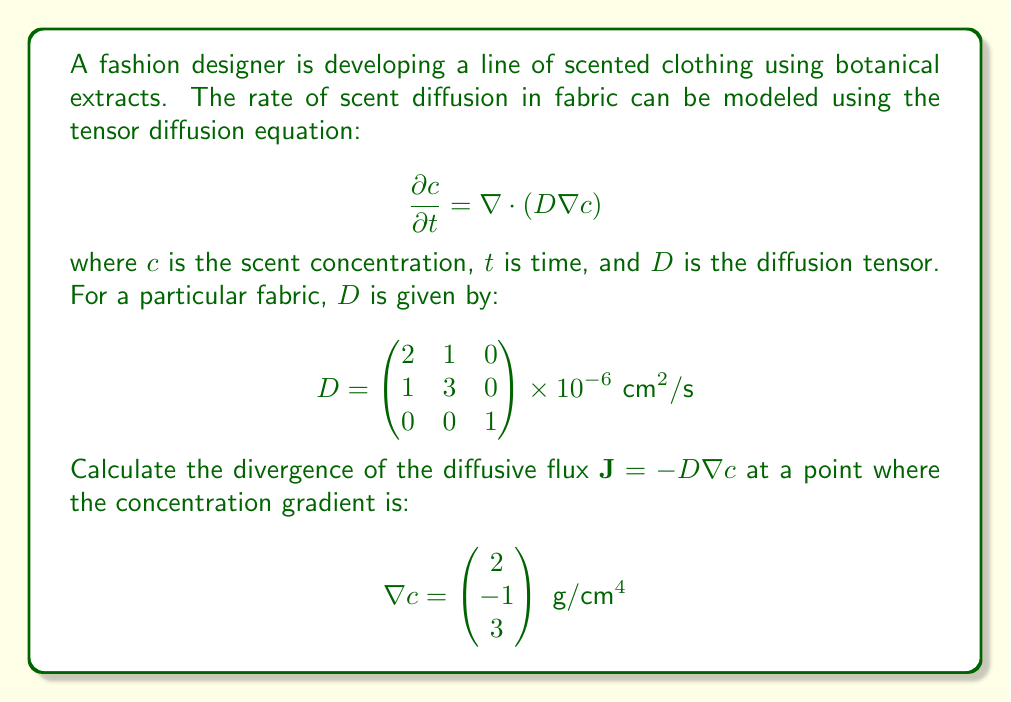Can you solve this math problem? Let's approach this step-by-step:

1) First, we need to calculate the diffusive flux $\mathbf{J} = -D \nabla c$:

   $$\mathbf{J} = -\begin{pmatrix} 
   2 & 1 & 0 \\
   1 & 3 & 0 \\
   0 & 0 & 1
   \end{pmatrix} \times 10^{-6} \begin{pmatrix} 
   2 \\
   -1 \\
   3
   \end{pmatrix}$$

2) Performing the matrix multiplication:

   $$\mathbf{J} = -\begin{pmatrix} 
   (2 \times 2 + 1 \times (-1) + 0 \times 3) \times 10^{-6} \\
   (1 \times 2 + 3 \times (-1) + 0 \times 3) \times 10^{-6} \\
   (0 \times 2 + 0 \times (-1) + 1 \times 3) \times 10^{-6}
   \end{pmatrix}$$

3) Simplifying:

   $$\mathbf{J} = -\begin{pmatrix} 
   3 \times 10^{-6} \\
   -1 \times 10^{-6} \\
   3 \times 10^{-6}
   \end{pmatrix} \text{ g}/(\text{cm}^2\text{s})$$

4) Now, we need to calculate the divergence of $\mathbf{J}$. The divergence is given by:

   $$\nabla \cdot \mathbf{J} = \frac{\partial J_x}{\partial x} + \frac{\partial J_y}{\partial y} + \frac{\partial J_z}{\partial z}$$

5) Since $\mathbf{J}$ is constant with respect to position, its partial derivatives are zero. Therefore:

   $$\nabla \cdot \mathbf{J} = 0 + 0 + 0 = 0$$

Thus, the divergence of the diffusive flux is zero.
Answer: $0 \text{ g}/(\text{cm}^3\text{s})$ 